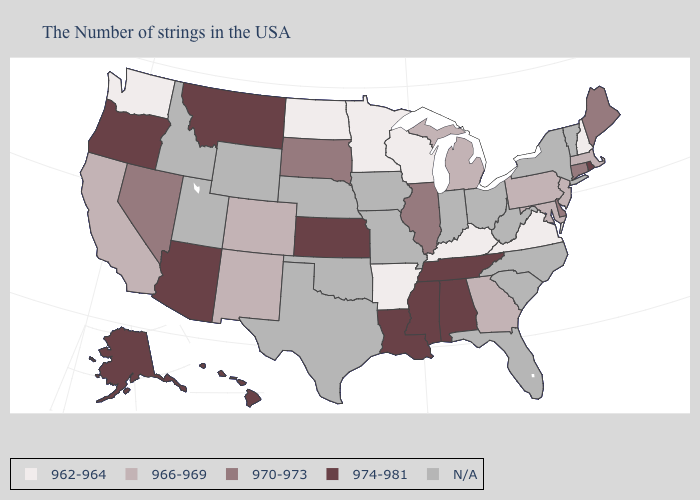Which states have the lowest value in the MidWest?
Quick response, please. Wisconsin, Minnesota, North Dakota. Does the first symbol in the legend represent the smallest category?
Give a very brief answer. Yes. What is the value of Hawaii?
Write a very short answer. 974-981. Name the states that have a value in the range 974-981?
Give a very brief answer. Rhode Island, Alabama, Tennessee, Mississippi, Louisiana, Kansas, Montana, Arizona, Oregon, Alaska, Hawaii. Does Tennessee have the lowest value in the USA?
Answer briefly. No. Is the legend a continuous bar?
Write a very short answer. No. What is the value of Virginia?
Concise answer only. 962-964. What is the value of Rhode Island?
Concise answer only. 974-981. Among the states that border New Hampshire , which have the highest value?
Be succinct. Maine. What is the value of Connecticut?
Keep it brief. 970-973. Does Alaska have the highest value in the USA?
Be succinct. Yes. What is the highest value in states that border Nebraska?
Short answer required. 974-981. Is the legend a continuous bar?
Short answer required. No. 